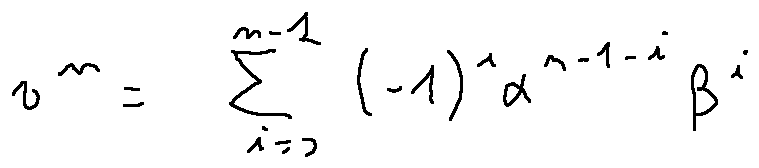Convert formula to latex. <formula><loc_0><loc_0><loc_500><loc_500>v ^ { n } = \sum \lim i t s _ { i = 0 } ^ { n - 1 } ( - 1 ) ^ { i } \alpha ^ { n - 1 - i } \beta ^ { i }</formula> 